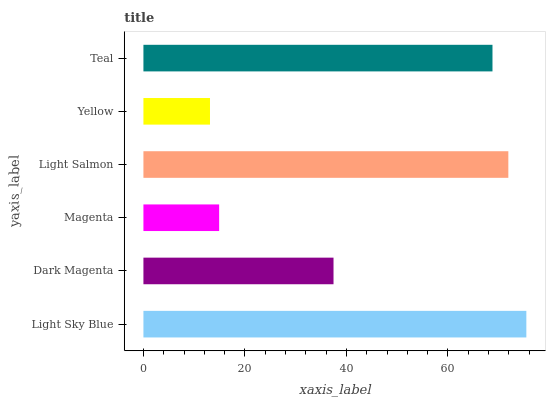Is Yellow the minimum?
Answer yes or no. Yes. Is Light Sky Blue the maximum?
Answer yes or no. Yes. Is Dark Magenta the minimum?
Answer yes or no. No. Is Dark Magenta the maximum?
Answer yes or no. No. Is Light Sky Blue greater than Dark Magenta?
Answer yes or no. Yes. Is Dark Magenta less than Light Sky Blue?
Answer yes or no. Yes. Is Dark Magenta greater than Light Sky Blue?
Answer yes or no. No. Is Light Sky Blue less than Dark Magenta?
Answer yes or no. No. Is Teal the high median?
Answer yes or no. Yes. Is Dark Magenta the low median?
Answer yes or no. Yes. Is Dark Magenta the high median?
Answer yes or no. No. Is Yellow the low median?
Answer yes or no. No. 